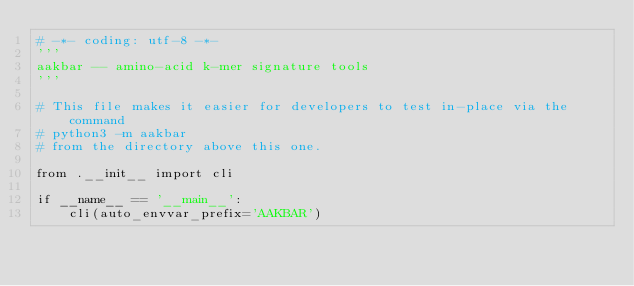Convert code to text. <code><loc_0><loc_0><loc_500><loc_500><_Python_># -*- coding: utf-8 -*-
'''
aakbar -- amino-acid k-mer signature tools
'''

# This file makes it easier for developers to test in-place via the command
# python3 -m aakbar
# from the directory above this one.

from .__init__ import cli

if __name__ == '__main__':
    cli(auto_envvar_prefix='AAKBAR')
</code> 